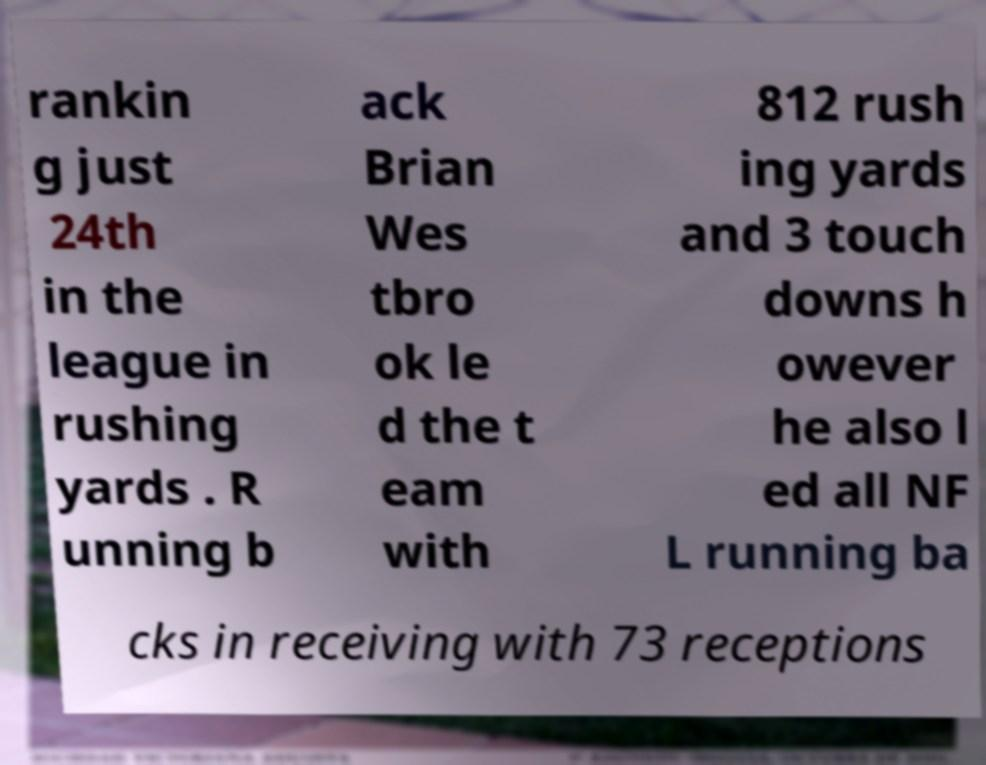For documentation purposes, I need the text within this image transcribed. Could you provide that? rankin g just 24th in the league in rushing yards . R unning b ack Brian Wes tbro ok le d the t eam with 812 rush ing yards and 3 touch downs h owever he also l ed all NF L running ba cks in receiving with 73 receptions 